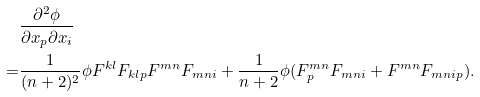<formula> <loc_0><loc_0><loc_500><loc_500>& \frac { \partial ^ { 2 } \phi } { \partial x _ { p } \partial x _ { i } } \\ = & { \frac { 1 } { ( n + 2 ) ^ { 2 } } } \phi F ^ { k l } F _ { k l p } F ^ { m n } F _ { m n i } + { \frac { 1 } { n + 2 } } \phi ( F _ { p } ^ { m n } F _ { m n i } + F ^ { m n } F _ { m n i p } ) . \\</formula> 